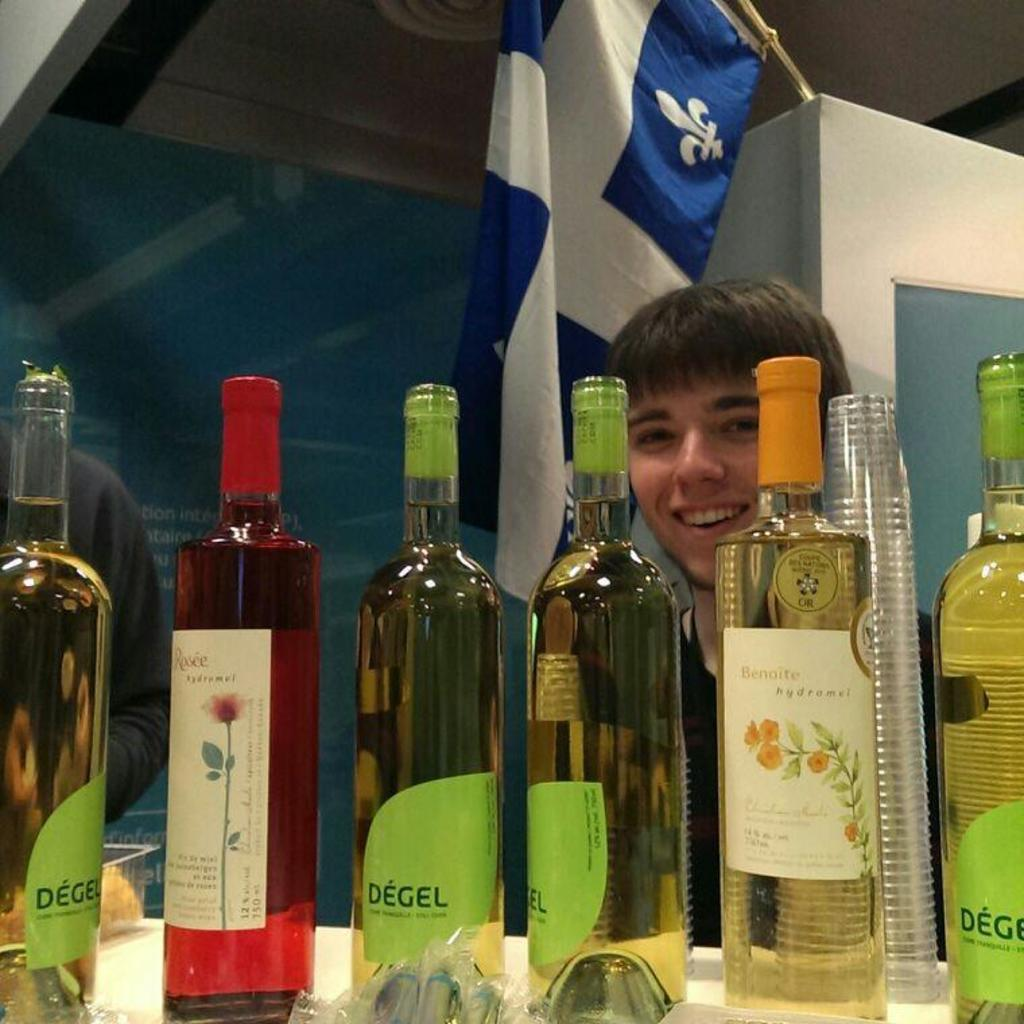<image>
Create a compact narrative representing the image presented. Person behind bottles with a green label that says DEGEL. 